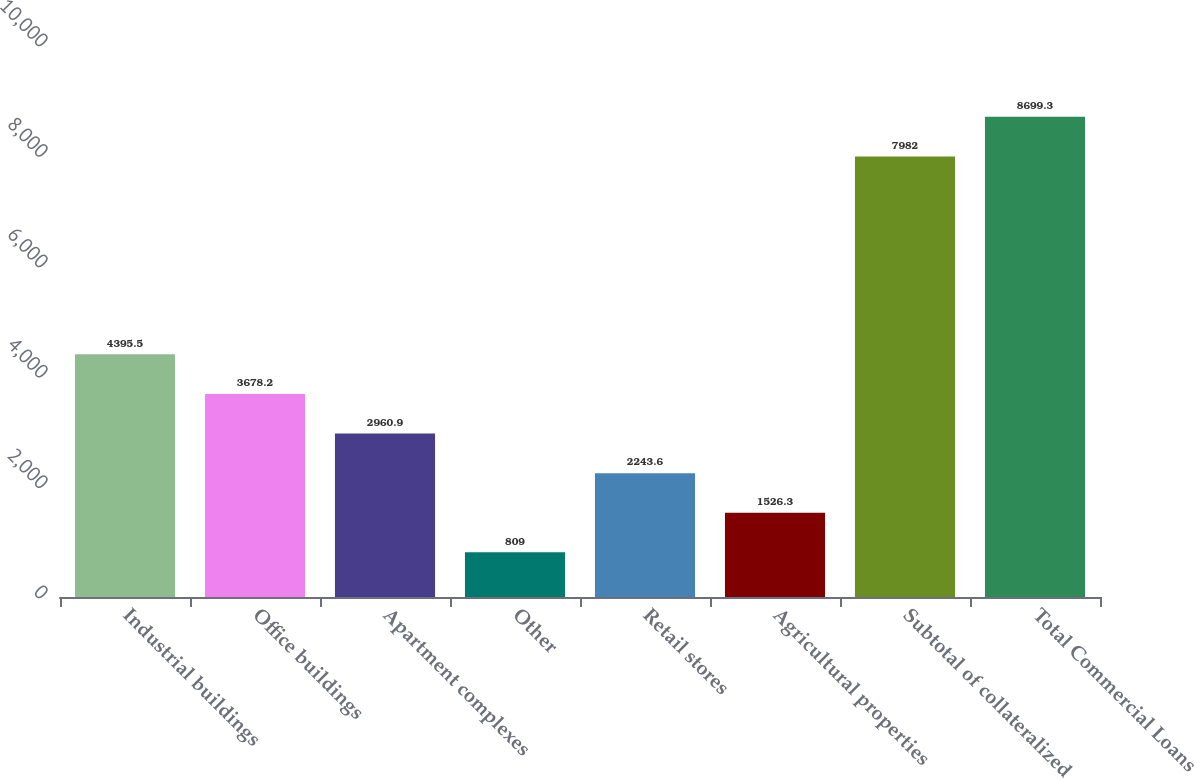Convert chart. <chart><loc_0><loc_0><loc_500><loc_500><bar_chart><fcel>Industrial buildings<fcel>Office buildings<fcel>Apartment complexes<fcel>Other<fcel>Retail stores<fcel>Agricultural properties<fcel>Subtotal of collateralized<fcel>Total Commercial Loans<nl><fcel>4395.5<fcel>3678.2<fcel>2960.9<fcel>809<fcel>2243.6<fcel>1526.3<fcel>7982<fcel>8699.3<nl></chart> 